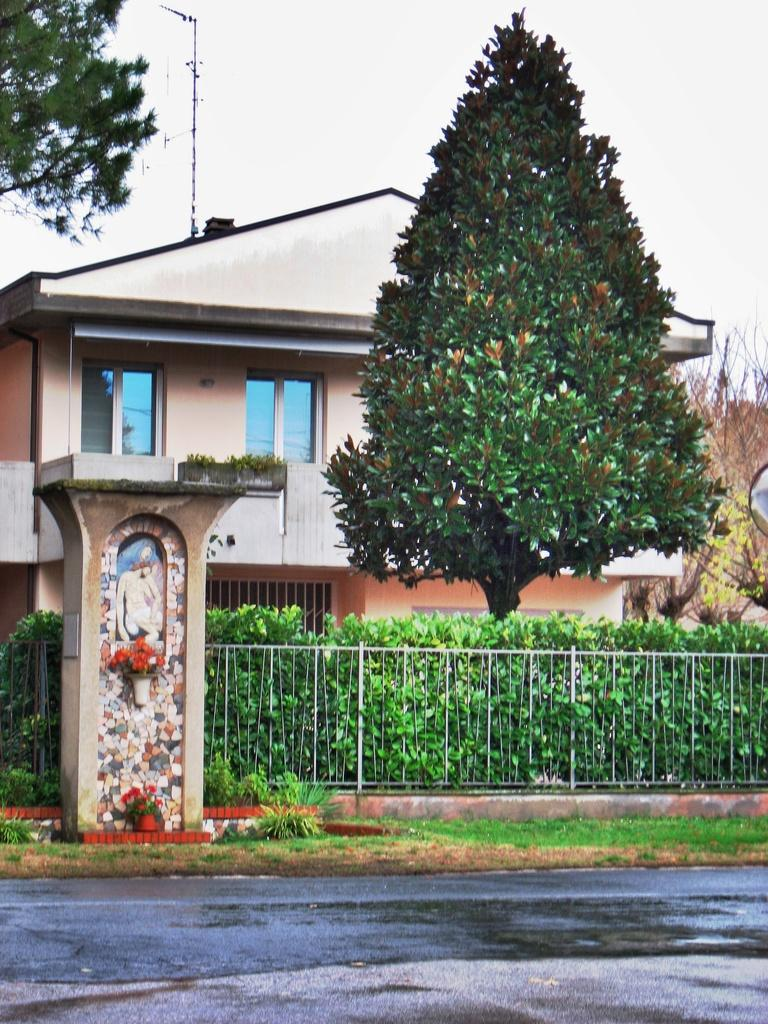What type of pathway is visible in the image? There is a road in the image. What structure can be seen in the image? There is a pillar in the image. What type of vegetation is present in the image? There are flowers, shrubs, and trees in the image. What type of building is visible in the image? There is a house in the image. What is visible in the background of the image? The sky is visible in the background of the image. What color is the sock hanging from the tree in the image? There is no sock present in the image; it only features a road, pillar, flowers, shrubs, trees, a house, and the sky in the background. 